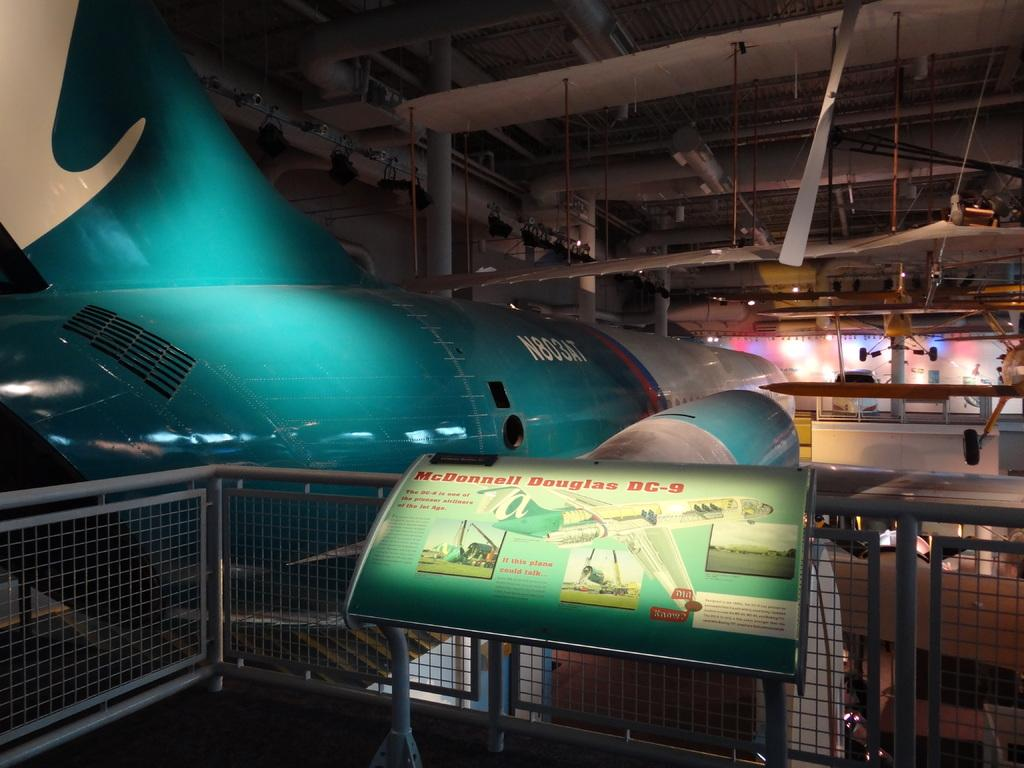<image>
Share a concise interpretation of the image provided. McDonnell Douglas DC-9 sign about the incredible plane. 